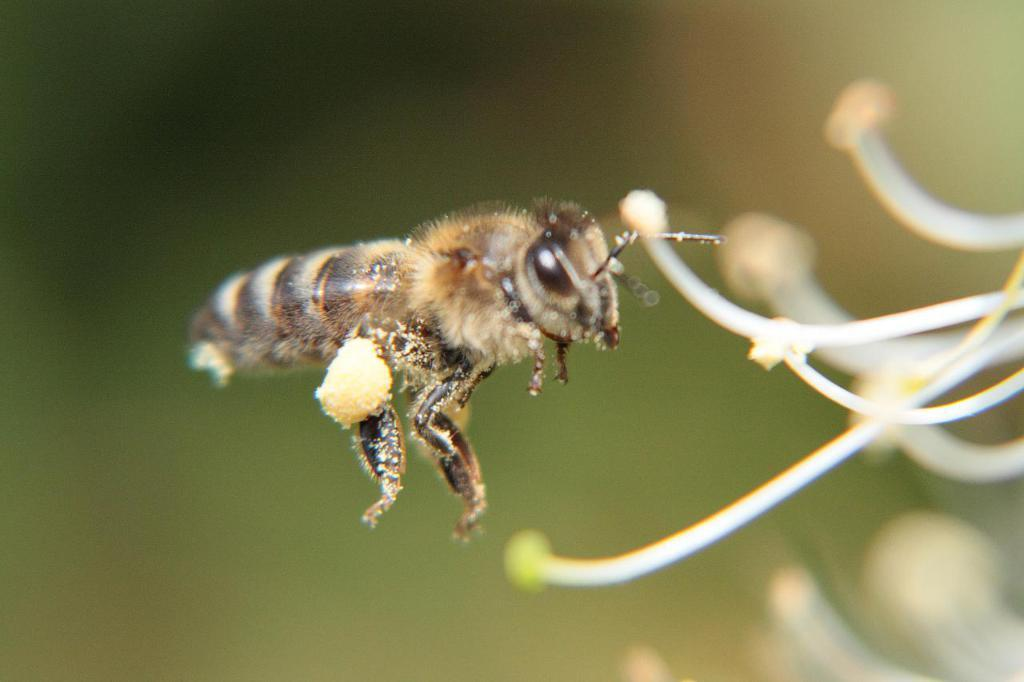What type of creature is present in the image? There is an insect in the image. Can you describe the color pattern of the insect? The insect has brown and cream colors. What can be observed about the background of the image? The background of the image is blurred. What type of chair is visible in the image? There is no chair present in the image; it features an insect with brown and cream colors against a blurred background. 